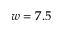Convert formula to latex. <formula><loc_0><loc_0><loc_500><loc_500>w = 7 . 5</formula> 